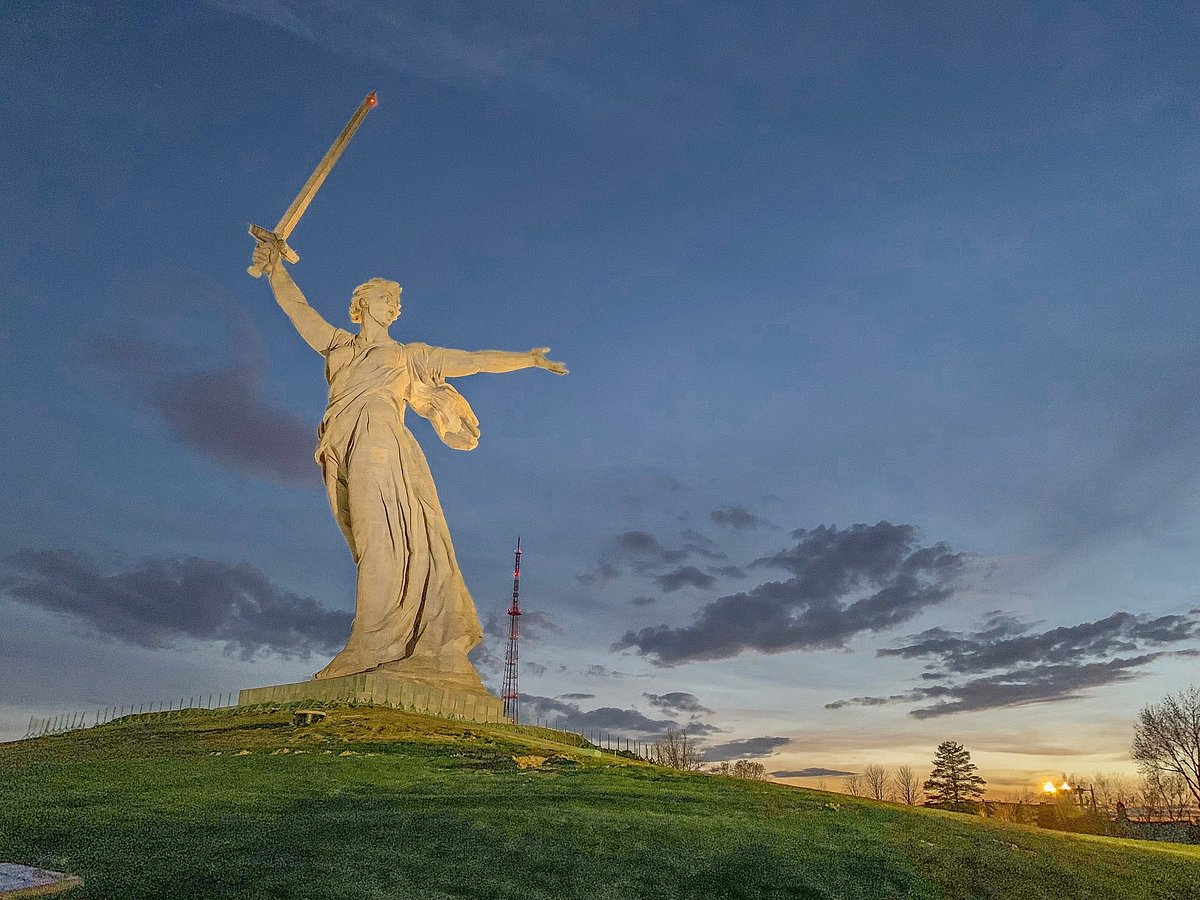Create an imaginative story based on the image. In the twilight of an ancient realm where history and legend intertwine, the statue known as 'The Motherland Calls' was not merely a monument but a dormant sentinel set to awaken in times of dire need. Guardians of the realm believed it harbored the spirit of a powerful warrior queen, whose strength and courage were unparalleled. One fateful evening, as shadows lengthened and the sky blazed with the fiery hues of sunset, an ominous rift opened in the heavens. Misty tendrils seeped into the mortal world, heralding the arrival of an otherworldly threat. The once-still form of the statue began to pulse with life. The stone softened, transforming into living flesh as the warrior queen emerged, sword gleaming with ethereal light. Trees rustled and whispered messages of an impending clash, and the radio tower began to hum with arcane energy, signaling allies far and wide. Birds took to the skies, shrieking in anticipation, as the Guardian Griffin materialized beside the queen, ready to heed her command. United, they charged towards the unknown, embodying the hopes and dreams of their land. As the battlefield lit up with ghostly fire, the warrior queen's indomitable spirit led the charge, pushing back the encroaching darkness and reminding all of the enduring power of courage and unity. Thus, the legend of 'The Motherland Calls' etched itself deeper into the lore of the realm, a testament to the timeless battle between light and darkness. 